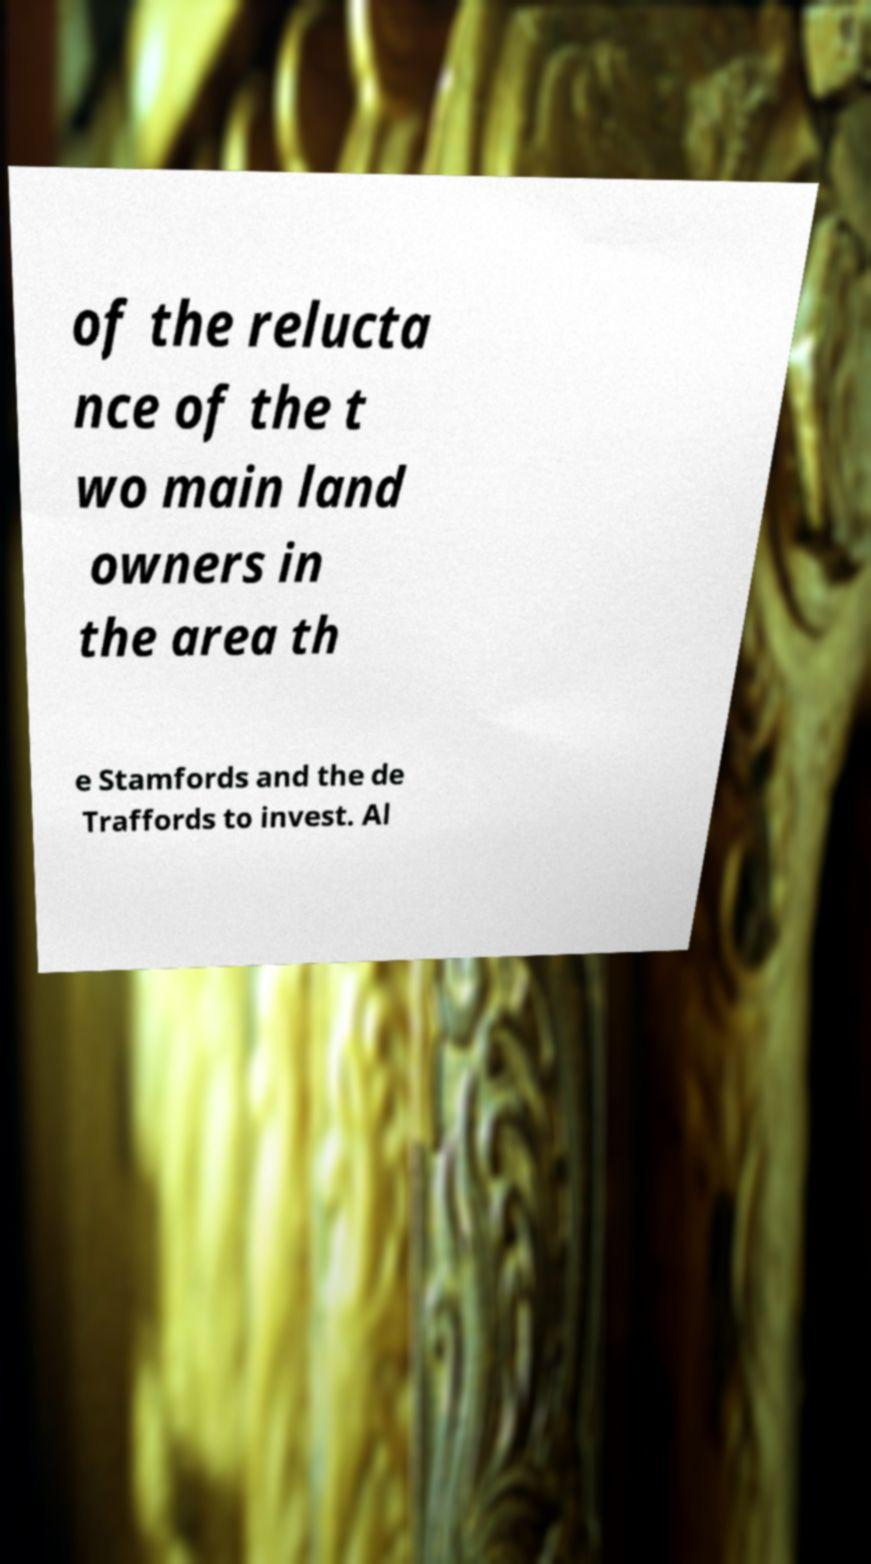For documentation purposes, I need the text within this image transcribed. Could you provide that? of the relucta nce of the t wo main land owners in the area th e Stamfords and the de Traffords to invest. Al 